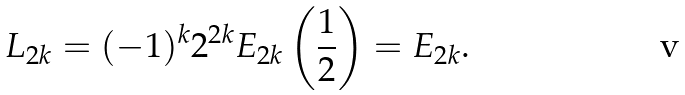<formula> <loc_0><loc_0><loc_500><loc_500>L _ { 2 k } = ( - 1 ) ^ { k } 2 ^ { 2 k } E _ { 2 k } \left ( \frac { 1 } { 2 } \right ) = E _ { 2 k } .</formula> 